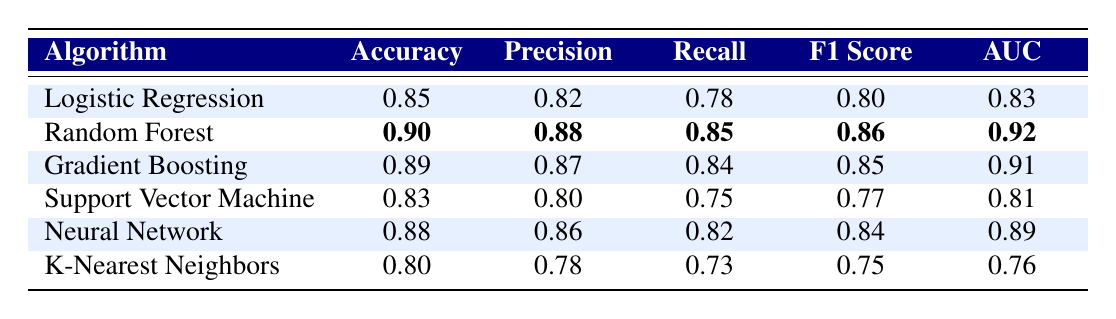What is the accuracy of the Random Forest algorithm? Referring to the table, the accuracy value corresponding to the Random Forest algorithm is given as 0.90.
Answer: 0.90 Which algorithm has the highest F1 Score? The F1 Score values shown in the table indicate that Random Forest has the highest F1 Score of 0.86 compared to the other algorithms listed.
Answer: Random Forest What is the difference in AUC between K-Nearest Neighbors and Gradient Boosting? From the table, the AUC of K-Nearest Neighbors is 0.76, and for Gradient Boosting, it is 0.91. The difference is calculated as 0.91 - 0.76 = 0.15.
Answer: 0.15 Is the recall of the Neural Network higher than that of the Support Vector Machine? The table shows a recall of 0.82 for the Neural Network and 0.75 for the Support Vector Machine. Since 0.82 is greater than 0.75, the statement is true.
Answer: Yes What is the average accuracy of all algorithms listed in the table? To find the average accuracy, add all accuracy values: (0.85 + 0.90 + 0.89 + 0.83 + 0.88 + 0.80) = 5.15. There are 6 algorithms, so the average is 5.15 / 6 = 0.85833, which can be approximated to 0.86 for simplicity.
Answer: 0.86 